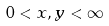Convert formula to latex. <formula><loc_0><loc_0><loc_500><loc_500>0 < x , y < \infty</formula> 